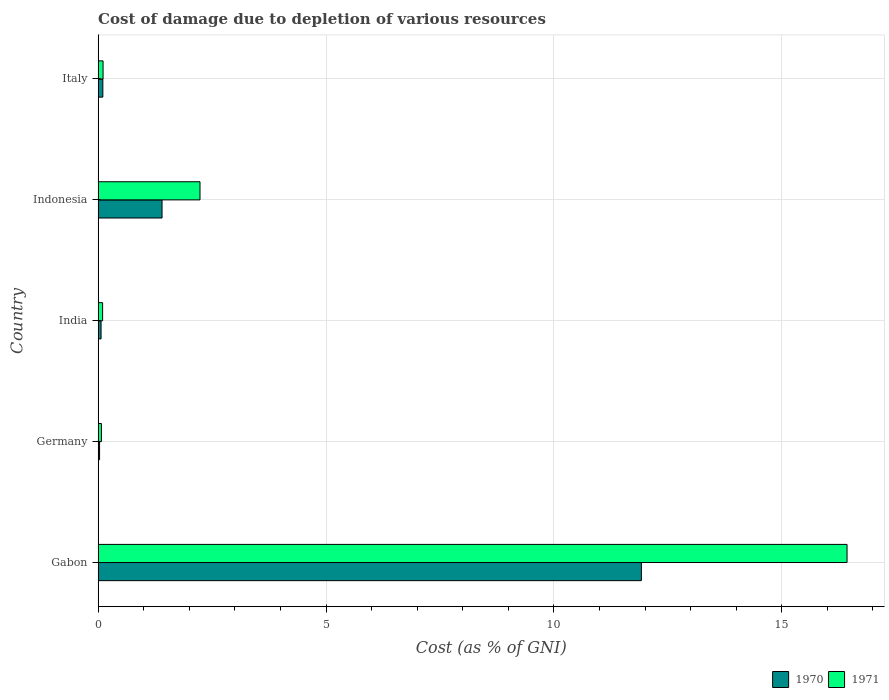How many different coloured bars are there?
Your response must be concise. 2. Are the number of bars per tick equal to the number of legend labels?
Offer a terse response. Yes. Are the number of bars on each tick of the Y-axis equal?
Provide a succinct answer. Yes. What is the cost of damage caused due to the depletion of various resources in 1971 in Indonesia?
Provide a succinct answer. 2.24. Across all countries, what is the maximum cost of damage caused due to the depletion of various resources in 1971?
Offer a very short reply. 16.43. Across all countries, what is the minimum cost of damage caused due to the depletion of various resources in 1971?
Your answer should be compact. 0.07. In which country was the cost of damage caused due to the depletion of various resources in 1971 maximum?
Your answer should be compact. Gabon. In which country was the cost of damage caused due to the depletion of various resources in 1971 minimum?
Make the answer very short. Germany. What is the total cost of damage caused due to the depletion of various resources in 1970 in the graph?
Your answer should be very brief. 13.52. What is the difference between the cost of damage caused due to the depletion of various resources in 1970 in Gabon and that in India?
Your response must be concise. 11.85. What is the difference between the cost of damage caused due to the depletion of various resources in 1971 in India and the cost of damage caused due to the depletion of various resources in 1970 in Gabon?
Give a very brief answer. -11.82. What is the average cost of damage caused due to the depletion of various resources in 1970 per country?
Your answer should be very brief. 2.7. What is the difference between the cost of damage caused due to the depletion of various resources in 1970 and cost of damage caused due to the depletion of various resources in 1971 in Germany?
Your answer should be very brief. -0.04. What is the ratio of the cost of damage caused due to the depletion of various resources in 1971 in Indonesia to that in Italy?
Your answer should be very brief. 20.58. Is the cost of damage caused due to the depletion of various resources in 1971 in India less than that in Indonesia?
Offer a terse response. Yes. What is the difference between the highest and the second highest cost of damage caused due to the depletion of various resources in 1971?
Ensure brevity in your answer.  14.2. What is the difference between the highest and the lowest cost of damage caused due to the depletion of various resources in 1970?
Provide a succinct answer. 11.89. In how many countries, is the cost of damage caused due to the depletion of various resources in 1971 greater than the average cost of damage caused due to the depletion of various resources in 1971 taken over all countries?
Provide a succinct answer. 1. Is the sum of the cost of damage caused due to the depletion of various resources in 1971 in Gabon and Italy greater than the maximum cost of damage caused due to the depletion of various resources in 1970 across all countries?
Make the answer very short. Yes. What does the 1st bar from the bottom in Germany represents?
Keep it short and to the point. 1970. How many bars are there?
Keep it short and to the point. 10. Are all the bars in the graph horizontal?
Keep it short and to the point. Yes. How many countries are there in the graph?
Your answer should be compact. 5. What is the difference between two consecutive major ticks on the X-axis?
Your answer should be compact. 5. Are the values on the major ticks of X-axis written in scientific E-notation?
Give a very brief answer. No. How are the legend labels stacked?
Provide a short and direct response. Horizontal. What is the title of the graph?
Give a very brief answer. Cost of damage due to depletion of various resources. What is the label or title of the X-axis?
Offer a very short reply. Cost (as % of GNI). What is the label or title of the Y-axis?
Keep it short and to the point. Country. What is the Cost (as % of GNI) of 1970 in Gabon?
Provide a succinct answer. 11.92. What is the Cost (as % of GNI) in 1971 in Gabon?
Your answer should be compact. 16.43. What is the Cost (as % of GNI) in 1970 in Germany?
Keep it short and to the point. 0.03. What is the Cost (as % of GNI) of 1971 in Germany?
Keep it short and to the point. 0.07. What is the Cost (as % of GNI) of 1970 in India?
Your answer should be very brief. 0.06. What is the Cost (as % of GNI) of 1971 in India?
Offer a terse response. 0.1. What is the Cost (as % of GNI) in 1970 in Indonesia?
Give a very brief answer. 1.4. What is the Cost (as % of GNI) in 1971 in Indonesia?
Make the answer very short. 2.24. What is the Cost (as % of GNI) of 1970 in Italy?
Your answer should be very brief. 0.1. What is the Cost (as % of GNI) in 1971 in Italy?
Provide a short and direct response. 0.11. Across all countries, what is the maximum Cost (as % of GNI) in 1970?
Offer a terse response. 11.92. Across all countries, what is the maximum Cost (as % of GNI) of 1971?
Your answer should be compact. 16.43. Across all countries, what is the minimum Cost (as % of GNI) of 1970?
Your response must be concise. 0.03. Across all countries, what is the minimum Cost (as % of GNI) in 1971?
Your response must be concise. 0.07. What is the total Cost (as % of GNI) of 1970 in the graph?
Your response must be concise. 13.52. What is the total Cost (as % of GNI) in 1971 in the graph?
Ensure brevity in your answer.  18.95. What is the difference between the Cost (as % of GNI) of 1970 in Gabon and that in Germany?
Keep it short and to the point. 11.89. What is the difference between the Cost (as % of GNI) in 1971 in Gabon and that in Germany?
Your response must be concise. 16.36. What is the difference between the Cost (as % of GNI) in 1970 in Gabon and that in India?
Ensure brevity in your answer.  11.86. What is the difference between the Cost (as % of GNI) of 1971 in Gabon and that in India?
Your response must be concise. 16.33. What is the difference between the Cost (as % of GNI) of 1970 in Gabon and that in Indonesia?
Offer a very short reply. 10.52. What is the difference between the Cost (as % of GNI) in 1971 in Gabon and that in Indonesia?
Keep it short and to the point. 14.2. What is the difference between the Cost (as % of GNI) in 1970 in Gabon and that in Italy?
Your answer should be very brief. 11.82. What is the difference between the Cost (as % of GNI) in 1971 in Gabon and that in Italy?
Ensure brevity in your answer.  16.32. What is the difference between the Cost (as % of GNI) of 1970 in Germany and that in India?
Provide a short and direct response. -0.03. What is the difference between the Cost (as % of GNI) of 1971 in Germany and that in India?
Offer a terse response. -0.03. What is the difference between the Cost (as % of GNI) in 1970 in Germany and that in Indonesia?
Make the answer very short. -1.37. What is the difference between the Cost (as % of GNI) in 1971 in Germany and that in Indonesia?
Make the answer very short. -2.16. What is the difference between the Cost (as % of GNI) in 1970 in Germany and that in Italy?
Give a very brief answer. -0.07. What is the difference between the Cost (as % of GNI) of 1971 in Germany and that in Italy?
Provide a short and direct response. -0.04. What is the difference between the Cost (as % of GNI) in 1970 in India and that in Indonesia?
Your response must be concise. -1.34. What is the difference between the Cost (as % of GNI) of 1971 in India and that in Indonesia?
Provide a short and direct response. -2.14. What is the difference between the Cost (as % of GNI) of 1970 in India and that in Italy?
Provide a succinct answer. -0.04. What is the difference between the Cost (as % of GNI) of 1971 in India and that in Italy?
Your response must be concise. -0.01. What is the difference between the Cost (as % of GNI) of 1970 in Indonesia and that in Italy?
Make the answer very short. 1.3. What is the difference between the Cost (as % of GNI) of 1971 in Indonesia and that in Italy?
Give a very brief answer. 2.13. What is the difference between the Cost (as % of GNI) of 1970 in Gabon and the Cost (as % of GNI) of 1971 in Germany?
Your answer should be very brief. 11.85. What is the difference between the Cost (as % of GNI) in 1970 in Gabon and the Cost (as % of GNI) in 1971 in India?
Provide a succinct answer. 11.82. What is the difference between the Cost (as % of GNI) in 1970 in Gabon and the Cost (as % of GNI) in 1971 in Indonesia?
Make the answer very short. 9.68. What is the difference between the Cost (as % of GNI) of 1970 in Gabon and the Cost (as % of GNI) of 1971 in Italy?
Offer a terse response. 11.81. What is the difference between the Cost (as % of GNI) of 1970 in Germany and the Cost (as % of GNI) of 1971 in India?
Ensure brevity in your answer.  -0.07. What is the difference between the Cost (as % of GNI) of 1970 in Germany and the Cost (as % of GNI) of 1971 in Indonesia?
Offer a terse response. -2.2. What is the difference between the Cost (as % of GNI) of 1970 in Germany and the Cost (as % of GNI) of 1971 in Italy?
Your response must be concise. -0.08. What is the difference between the Cost (as % of GNI) of 1970 in India and the Cost (as % of GNI) of 1971 in Indonesia?
Provide a succinct answer. -2.17. What is the difference between the Cost (as % of GNI) in 1970 in India and the Cost (as % of GNI) in 1971 in Italy?
Provide a short and direct response. -0.04. What is the difference between the Cost (as % of GNI) in 1970 in Indonesia and the Cost (as % of GNI) in 1971 in Italy?
Keep it short and to the point. 1.29. What is the average Cost (as % of GNI) of 1970 per country?
Provide a short and direct response. 2.7. What is the average Cost (as % of GNI) of 1971 per country?
Ensure brevity in your answer.  3.79. What is the difference between the Cost (as % of GNI) of 1970 and Cost (as % of GNI) of 1971 in Gabon?
Provide a succinct answer. -4.51. What is the difference between the Cost (as % of GNI) in 1970 and Cost (as % of GNI) in 1971 in Germany?
Ensure brevity in your answer.  -0.04. What is the difference between the Cost (as % of GNI) of 1970 and Cost (as % of GNI) of 1971 in India?
Ensure brevity in your answer.  -0.03. What is the difference between the Cost (as % of GNI) in 1970 and Cost (as % of GNI) in 1971 in Indonesia?
Make the answer very short. -0.83. What is the difference between the Cost (as % of GNI) in 1970 and Cost (as % of GNI) in 1971 in Italy?
Keep it short and to the point. -0. What is the ratio of the Cost (as % of GNI) in 1970 in Gabon to that in Germany?
Offer a very short reply. 372.66. What is the ratio of the Cost (as % of GNI) in 1971 in Gabon to that in Germany?
Your response must be concise. 226.83. What is the ratio of the Cost (as % of GNI) in 1970 in Gabon to that in India?
Make the answer very short. 184.89. What is the ratio of the Cost (as % of GNI) of 1971 in Gabon to that in India?
Offer a very short reply. 166.63. What is the ratio of the Cost (as % of GNI) of 1970 in Gabon to that in Indonesia?
Your answer should be compact. 8.5. What is the ratio of the Cost (as % of GNI) in 1971 in Gabon to that in Indonesia?
Offer a terse response. 7.35. What is the ratio of the Cost (as % of GNI) of 1970 in Gabon to that in Italy?
Keep it short and to the point. 114.98. What is the ratio of the Cost (as % of GNI) of 1971 in Gabon to that in Italy?
Provide a succinct answer. 151.29. What is the ratio of the Cost (as % of GNI) of 1970 in Germany to that in India?
Offer a terse response. 0.5. What is the ratio of the Cost (as % of GNI) in 1971 in Germany to that in India?
Your answer should be very brief. 0.73. What is the ratio of the Cost (as % of GNI) of 1970 in Germany to that in Indonesia?
Ensure brevity in your answer.  0.02. What is the ratio of the Cost (as % of GNI) in 1971 in Germany to that in Indonesia?
Provide a short and direct response. 0.03. What is the ratio of the Cost (as % of GNI) of 1970 in Germany to that in Italy?
Provide a short and direct response. 0.31. What is the ratio of the Cost (as % of GNI) in 1971 in Germany to that in Italy?
Ensure brevity in your answer.  0.67. What is the ratio of the Cost (as % of GNI) in 1970 in India to that in Indonesia?
Provide a short and direct response. 0.05. What is the ratio of the Cost (as % of GNI) of 1971 in India to that in Indonesia?
Offer a terse response. 0.04. What is the ratio of the Cost (as % of GNI) of 1970 in India to that in Italy?
Offer a very short reply. 0.62. What is the ratio of the Cost (as % of GNI) in 1971 in India to that in Italy?
Your answer should be compact. 0.91. What is the ratio of the Cost (as % of GNI) in 1970 in Indonesia to that in Italy?
Ensure brevity in your answer.  13.53. What is the ratio of the Cost (as % of GNI) in 1971 in Indonesia to that in Italy?
Your answer should be very brief. 20.58. What is the difference between the highest and the second highest Cost (as % of GNI) of 1970?
Offer a terse response. 10.52. What is the difference between the highest and the second highest Cost (as % of GNI) of 1971?
Provide a short and direct response. 14.2. What is the difference between the highest and the lowest Cost (as % of GNI) of 1970?
Give a very brief answer. 11.89. What is the difference between the highest and the lowest Cost (as % of GNI) in 1971?
Make the answer very short. 16.36. 